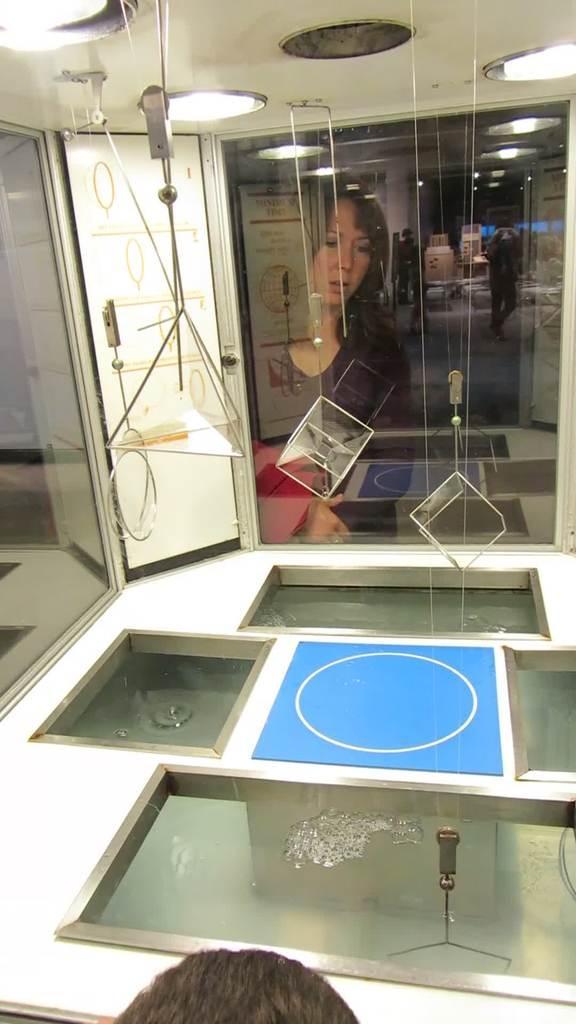In one or two sentences, can you explain what this image depicts? In the foreground of this picture, there is a head of a person on the bottom side of the image and a glass surface. there are few cubes and a prism are hanging to the ceiling. There are lights on the top. In the background, we can see a woman through the glass. 